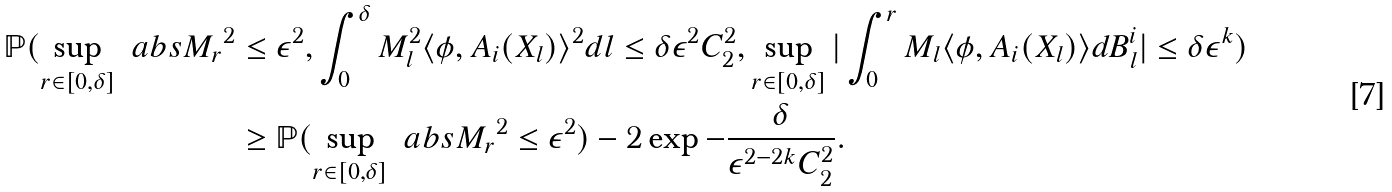Convert formula to latex. <formula><loc_0><loc_0><loc_500><loc_500>\mathbb { P } ( \sup _ { r \in [ 0 , \delta ] } \ a b s { M _ { r } } ^ { 2 } & \leq \epsilon ^ { 2 } , \int _ { 0 } ^ { \delta } M _ { l } ^ { 2 } \langle \phi , A _ { i } ( X _ { l } ) \rangle ^ { 2 } d l \leq \delta \epsilon ^ { 2 } C _ { 2 } ^ { 2 } , \sup _ { r \in [ 0 , \delta ] } | \int _ { 0 } ^ { r } M _ { l } \langle \phi , A _ { i } ( X _ { l } ) \rangle d B ^ { i } _ { l } | \leq \delta \epsilon ^ { k } ) \\ & \geq \mathbb { P } ( \sup _ { r \in [ 0 , \delta ] } \ a b s { M _ { r } } ^ { 2 } \leq \epsilon ^ { 2 } ) - 2 \exp { - \frac { \delta } { \epsilon ^ { 2 - 2 k } C _ { 2 } ^ { 2 } } } .</formula> 